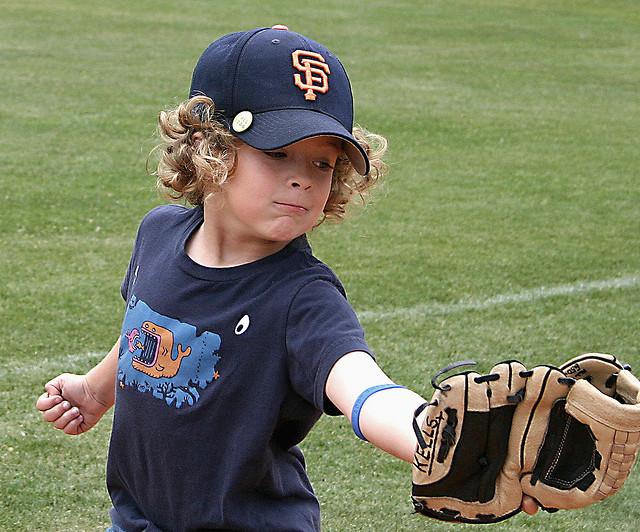What is the boy wearing in his hand?
Write a very short answer. Baseball glove. What team is on the kids hat?
Be succinct. San francisco giants. What TV cartoon is suggested on the boy's shirt?
Give a very brief answer. Spongebob. 